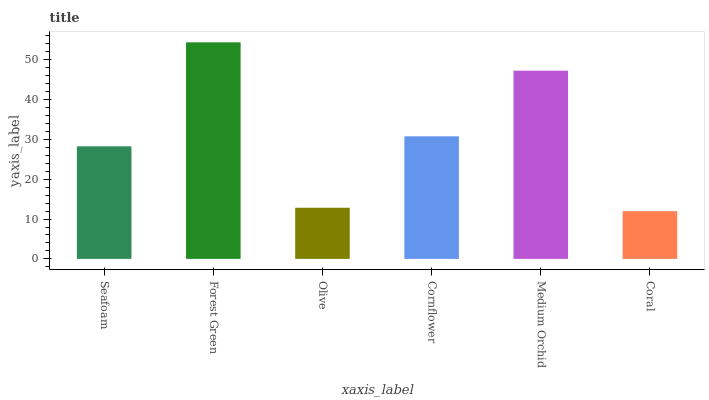Is Coral the minimum?
Answer yes or no. Yes. Is Forest Green the maximum?
Answer yes or no. Yes. Is Olive the minimum?
Answer yes or no. No. Is Olive the maximum?
Answer yes or no. No. Is Forest Green greater than Olive?
Answer yes or no. Yes. Is Olive less than Forest Green?
Answer yes or no. Yes. Is Olive greater than Forest Green?
Answer yes or no. No. Is Forest Green less than Olive?
Answer yes or no. No. Is Cornflower the high median?
Answer yes or no. Yes. Is Seafoam the low median?
Answer yes or no. Yes. Is Olive the high median?
Answer yes or no. No. Is Cornflower the low median?
Answer yes or no. No. 